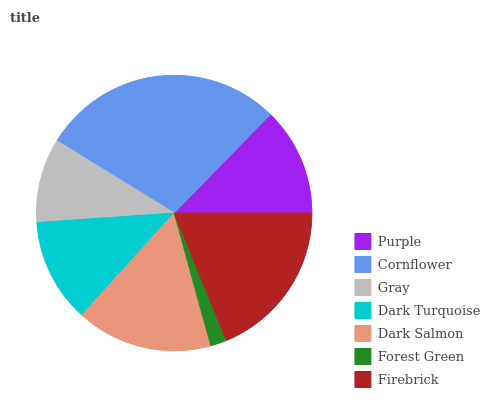Is Forest Green the minimum?
Answer yes or no. Yes. Is Cornflower the maximum?
Answer yes or no. Yes. Is Gray the minimum?
Answer yes or no. No. Is Gray the maximum?
Answer yes or no. No. Is Cornflower greater than Gray?
Answer yes or no. Yes. Is Gray less than Cornflower?
Answer yes or no. Yes. Is Gray greater than Cornflower?
Answer yes or no. No. Is Cornflower less than Gray?
Answer yes or no. No. Is Purple the high median?
Answer yes or no. Yes. Is Purple the low median?
Answer yes or no. Yes. Is Dark Turquoise the high median?
Answer yes or no. No. Is Dark Salmon the low median?
Answer yes or no. No. 